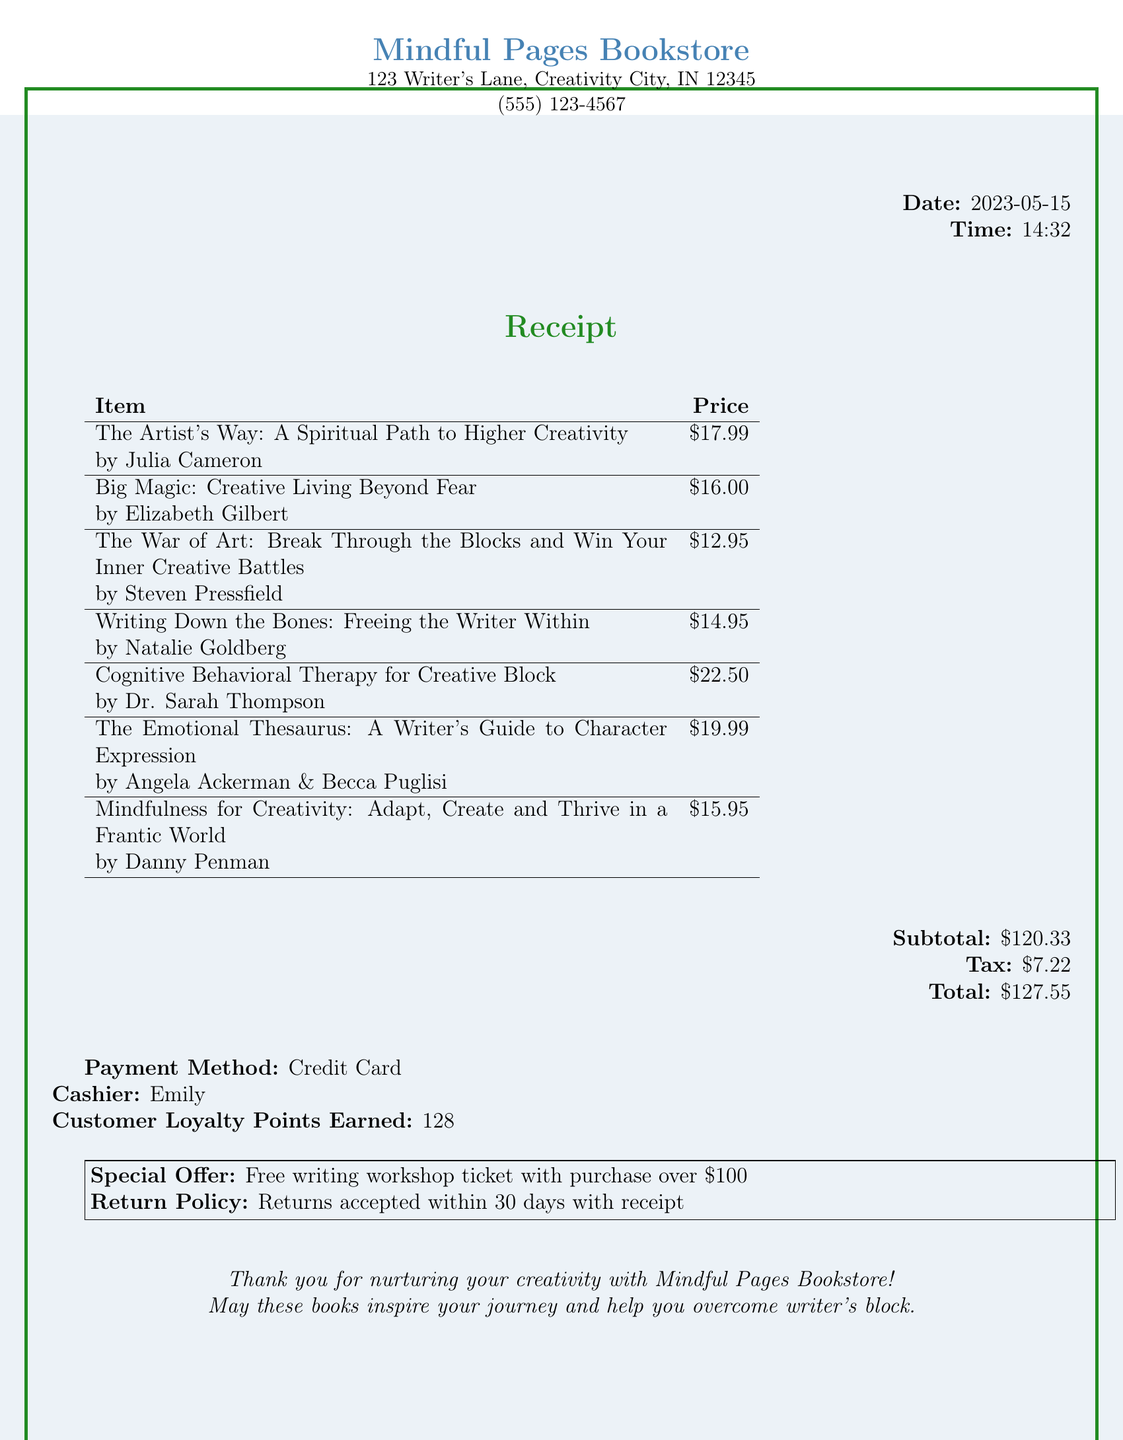What is the store's name? The store's name is found prominently at the top of the receipt.
Answer: Mindful Pages Bookstore What is the total amount spent? The total amount is the final amount due indicated at the bottom of the receipt.
Answer: 127.55 Who is the author of "The War of Art"? The author's name is specified next to the book title in the itemized list.
Answer: Steven Pressfield What is the date of the purchase? The date is shown in bold on the receipt.
Answer: 2023-05-15 How many loyalty points were earned? The number of loyalty points is mentioned towards the end of the receipt.
Answer: 128 What special offer was available with the purchase? The special offer is stated clearly in a box at the bottom of the receipt.
Answer: Free writing workshop ticket with purchase over $100 What type of payment was used? The payment method is indicated towards the end of the receipt.
Answer: Credit Card How many self-help books are listed on the receipt? The number of items can be counted from the itemized list.
Answer: 7 What is the subtotal before tax? The subtotal is presented just before the tax on the receipt.
Answer: 120.33 